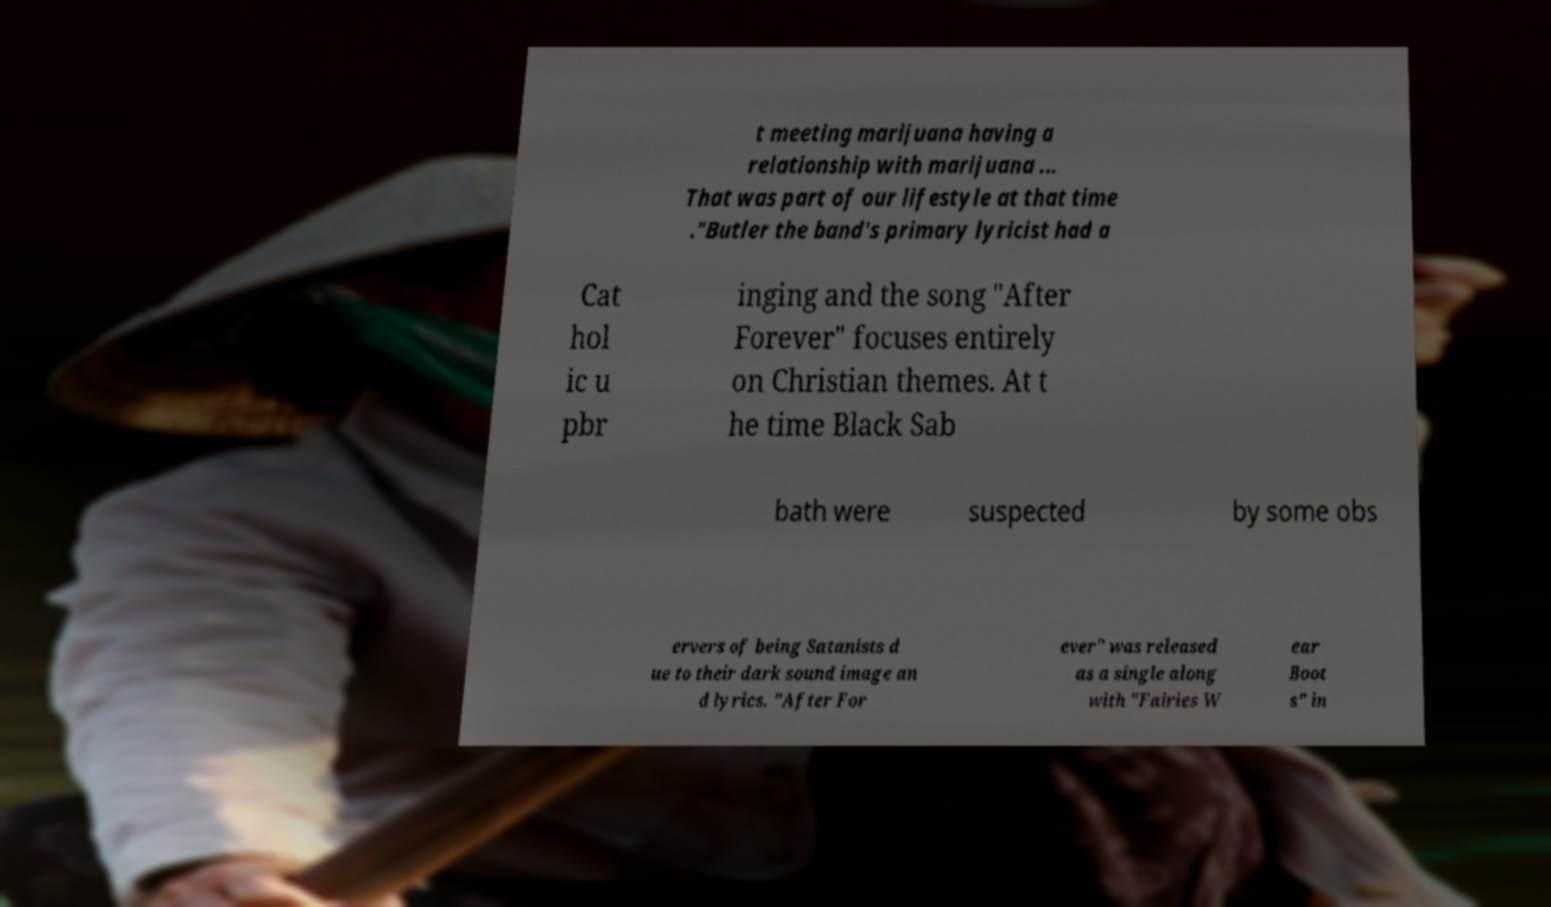Could you extract and type out the text from this image? t meeting marijuana having a relationship with marijuana ... That was part of our lifestyle at that time ."Butler the band's primary lyricist had a Cat hol ic u pbr inging and the song "After Forever" focuses entirely on Christian themes. At t he time Black Sab bath were suspected by some obs ervers of being Satanists d ue to their dark sound image an d lyrics. "After For ever" was released as a single along with "Fairies W ear Boot s" in 